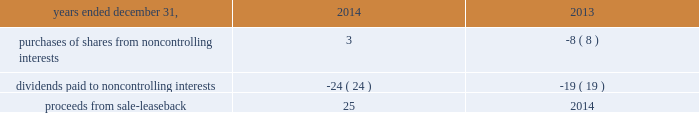Notes to consolidated financial statements 1 .
Basis of presentation the accompanying consolidated financial statements and notes thereto have been prepared in accordance with u.s .
Generally accepted accounting principles ( "u.s .
Gaap" ) .
The consolidated financial statements include the accounts of aon plc and all of its controlled subsidiaries ( "aon" or the "company" ) .
All intercompany accounts and transactions have been eliminated .
The consolidated financial statements include , in the opinion of management , all adjustments necessary to present fairly the company's consolidated financial position , results of operations and cash flows for all periods presented .
Reclassification certain amounts in prior years' consolidated financial statements and related notes have been reclassified to conform to the 2015 presentation .
In prior periods , long-term investments were included in investments in the consolidated statement of financial position .
These amounts are now included in other non-current assets in the consolidated statement of financial position , as shown in note 3 to these consolidated financial statements .
Long-term investments were $ 135 million at december 31 , 2015 and $ 143 million at december 31 , 2014 .
In prior periods , prepaid pensions were included in other non-current assets in the consolidated statement of financial position .
These amounts are now separately disclosed in the consolidated statement of financial position .
Prepaid pensions were $ 1033 million at december 31 , 2015 and $ 933 million at december 31 , 2014 .
Upon vesting of certain share-based payment arrangements , employees may elect to use a portion of the shares to satisfy tax withholding requirements , in which case aon makes a payment to the taxing authority on the employee 2019s behalf and remits the remaining shares to the employee .
The company has historically presented amounts due to taxing authorities within cash flows from operating activities in the consolidated statements of cash flows .
The amounts are now included in 201cissuance of shares for employee benefit plans 201d within cash flows from financing activities .
The company believes this presentation provides greater clarity into the operating and financing activities of the company as the substance and accounting for these transactions is that of a share repurchase .
It also aligns the company 2019s presentation to be consistent with industry practice .
Amounts reported in issuance of shares for employee benefit plans were $ 227 million , $ 170 million , and $ 120 million , respectively , for the years ended december 31 , 2015 , 2014 and 2013 .
These amounts , which were reclassified from accounts payable and accrued liabilities and other assets and liabilities , were $ 85 million and $ 85 million in 2014 , and $ 62 million and $ 58 million in 2013 , respectively .
Changes to the presentation in the consolidated statements of cash flows for 2014 and 2013 were made related to certain line items within financing activities .
The following line items and respective amounts have been aggregated in a new line item titled 201cnoncontrolling interests and other financing activities 201d within financing activities. .
Use of estimates the preparation of the accompanying consolidated financial statements in conformity with u.s .
Gaap requires management to make estimates and assumptions that affect the reported amounts of assets and liabilities , disclosures of contingent assets and liabilities at the date of the financial statements , and the reported amounts of reserves and expenses .
These estimates and assumptions are based on management's best estimates and judgments .
Management evaluates its estimates and assumptions on an ongoing basis using historical experience and other factors , including the current economic environment .
Management believes its estimates to be reasonable given the current facts available .
Aon adjusts such estimates and assumptions when facts and circumstances dictate .
Illiquid credit markets , volatile equity markets , and foreign currency exchange rate movements increase the uncertainty inherent in such estimates and assumptions .
As future events and their effects cannot be determined , among other factors , with precision , actual results could differ significantly from these estimates .
Changes in estimates resulting from continuing changes in the economic environment would , if applicable , be reflected in the financial statements in future periods. .
What was the change in the prepaid pensions from 2014 to 2015 in millions? 
Computations: (1033 - 933)
Answer: 100.0. 